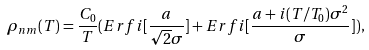<formula> <loc_0><loc_0><loc_500><loc_500>\rho _ { n m } ( T ) = \frac { C _ { 0 } } { T } ( E r f i [ \frac { a } { \sqrt { 2 } \sigma } ] + E r f i [ \frac { a + i ( T / T _ { 0 } ) \sigma ^ { 2 } } { \sigma } ] ) ,</formula> 